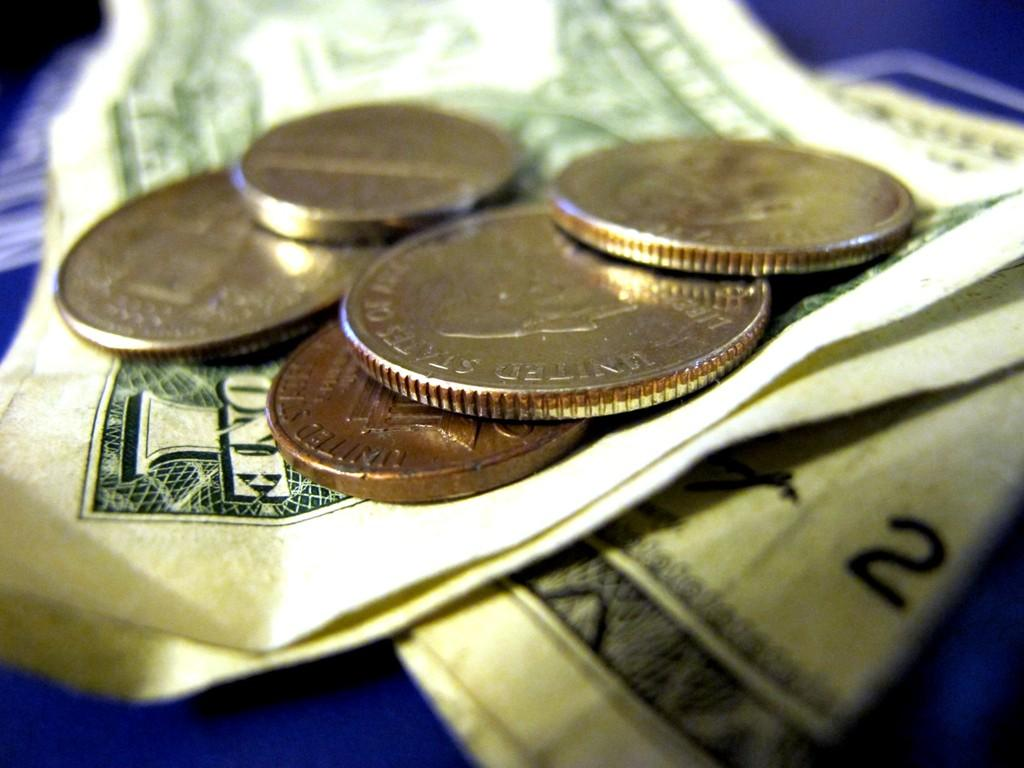<image>
Describe the image concisely. Five coins on top of three one dollar bills. 